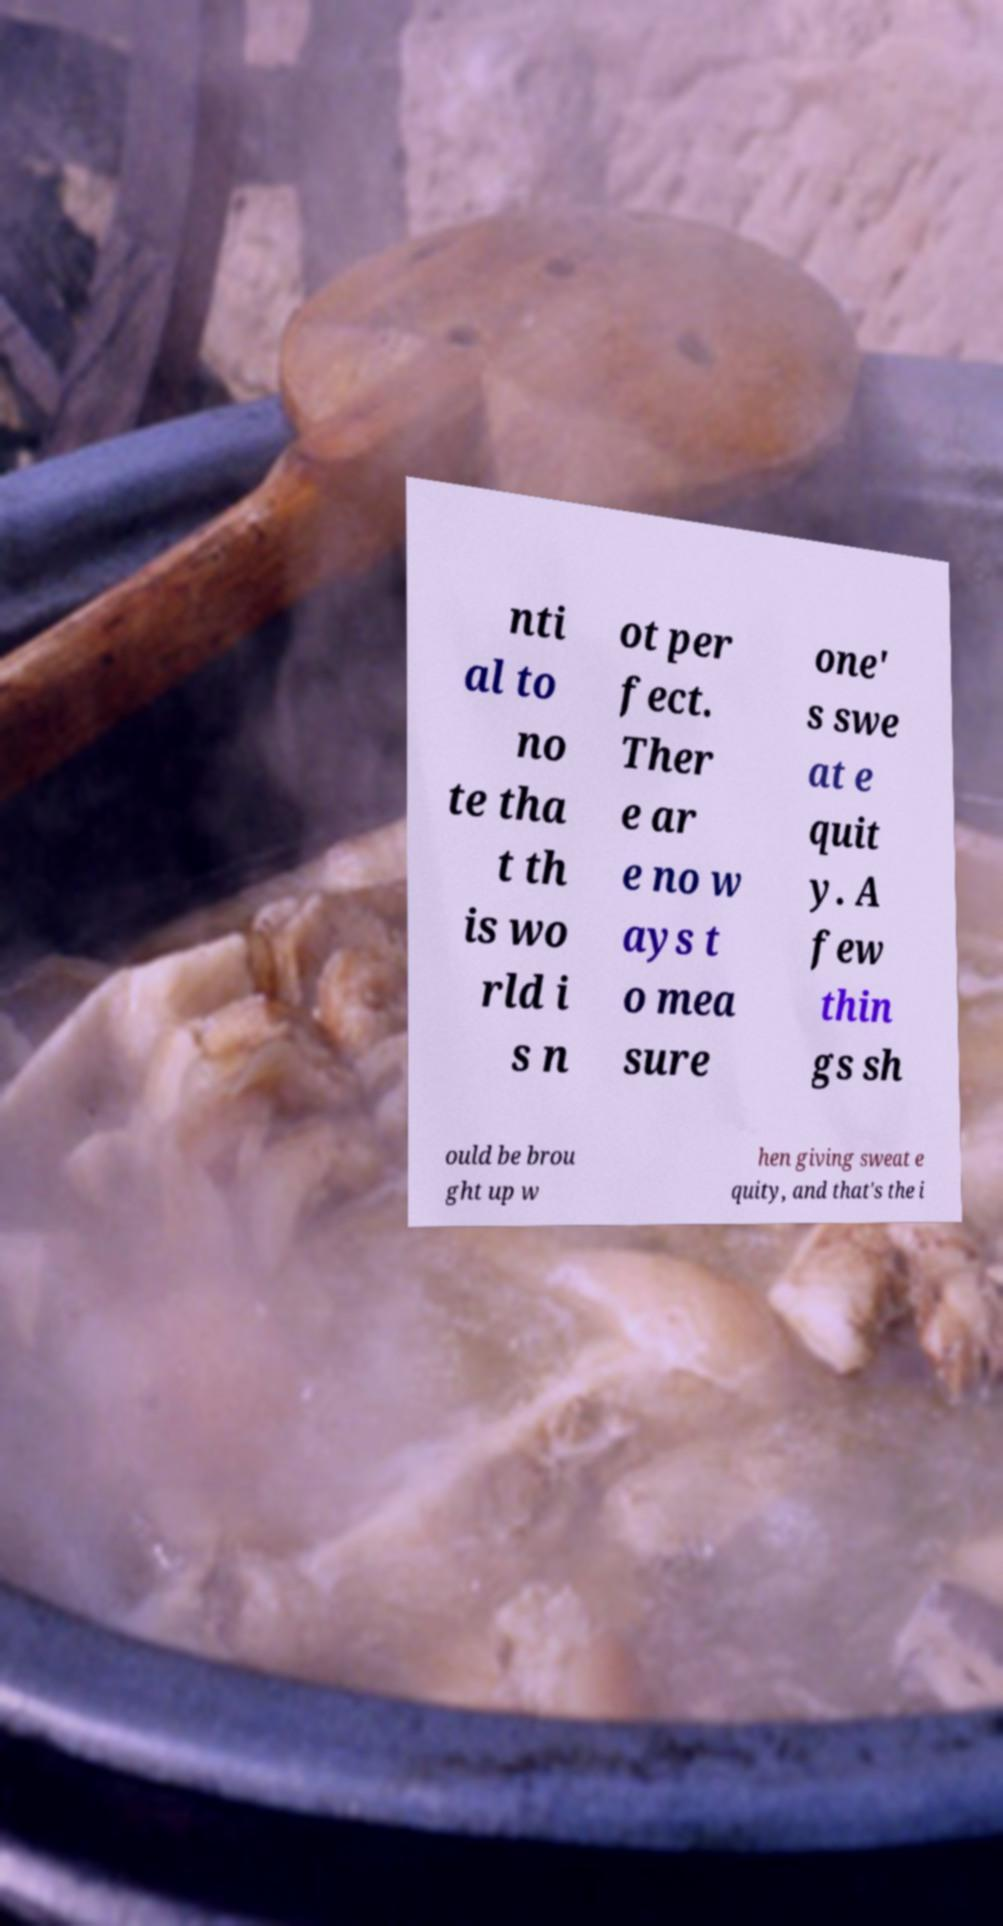There's text embedded in this image that I need extracted. Can you transcribe it verbatim? nti al to no te tha t th is wo rld i s n ot per fect. Ther e ar e no w ays t o mea sure one' s swe at e quit y. A few thin gs sh ould be brou ght up w hen giving sweat e quity, and that's the i 